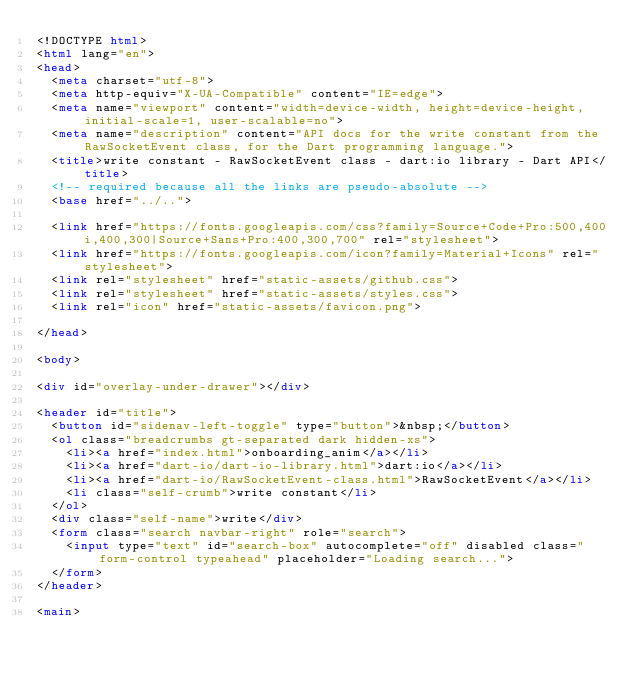<code> <loc_0><loc_0><loc_500><loc_500><_HTML_><!DOCTYPE html>
<html lang="en">
<head>
  <meta charset="utf-8">
  <meta http-equiv="X-UA-Compatible" content="IE=edge">
  <meta name="viewport" content="width=device-width, height=device-height, initial-scale=1, user-scalable=no">
  <meta name="description" content="API docs for the write constant from the RawSocketEvent class, for the Dart programming language.">
  <title>write constant - RawSocketEvent class - dart:io library - Dart API</title>
  <!-- required because all the links are pseudo-absolute -->
  <base href="../..">

  <link href="https://fonts.googleapis.com/css?family=Source+Code+Pro:500,400i,400,300|Source+Sans+Pro:400,300,700" rel="stylesheet">
  <link href="https://fonts.googleapis.com/icon?family=Material+Icons" rel="stylesheet">
  <link rel="stylesheet" href="static-assets/github.css">
  <link rel="stylesheet" href="static-assets/styles.css">
  <link rel="icon" href="static-assets/favicon.png">
  
</head>

<body>

<div id="overlay-under-drawer"></div>

<header id="title">
  <button id="sidenav-left-toggle" type="button">&nbsp;</button>
  <ol class="breadcrumbs gt-separated dark hidden-xs">
    <li><a href="index.html">onboarding_anim</a></li>
    <li><a href="dart-io/dart-io-library.html">dart:io</a></li>
    <li><a href="dart-io/RawSocketEvent-class.html">RawSocketEvent</a></li>
    <li class="self-crumb">write constant</li>
  </ol>
  <div class="self-name">write</div>
  <form class="search navbar-right" role="search">
    <input type="text" id="search-box" autocomplete="off" disabled class="form-control typeahead" placeholder="Loading search...">
  </form>
</header>

<main>
</code> 